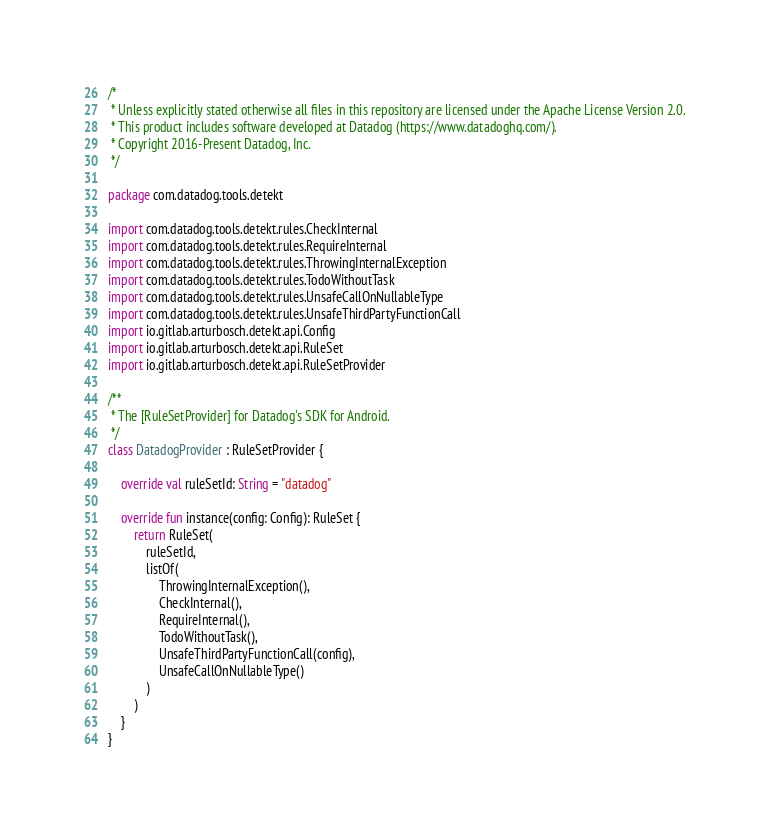Convert code to text. <code><loc_0><loc_0><loc_500><loc_500><_Kotlin_>/*
 * Unless explicitly stated otherwise all files in this repository are licensed under the Apache License Version 2.0.
 * This product includes software developed at Datadog (https://www.datadoghq.com/).
 * Copyright 2016-Present Datadog, Inc.
 */

package com.datadog.tools.detekt

import com.datadog.tools.detekt.rules.CheckInternal
import com.datadog.tools.detekt.rules.RequireInternal
import com.datadog.tools.detekt.rules.ThrowingInternalException
import com.datadog.tools.detekt.rules.TodoWithoutTask
import com.datadog.tools.detekt.rules.UnsafeCallOnNullableType
import com.datadog.tools.detekt.rules.UnsafeThirdPartyFunctionCall
import io.gitlab.arturbosch.detekt.api.Config
import io.gitlab.arturbosch.detekt.api.RuleSet
import io.gitlab.arturbosch.detekt.api.RuleSetProvider

/**
 * The [RuleSetProvider] for Datadog's SDK for Android.
 */
class DatadogProvider : RuleSetProvider {

    override val ruleSetId: String = "datadog"

    override fun instance(config: Config): RuleSet {
        return RuleSet(
            ruleSetId,
            listOf(
                ThrowingInternalException(),
                CheckInternal(),
                RequireInternal(),
                TodoWithoutTask(),
                UnsafeThirdPartyFunctionCall(config),
                UnsafeCallOnNullableType()
            )
        )
    }
}
</code> 